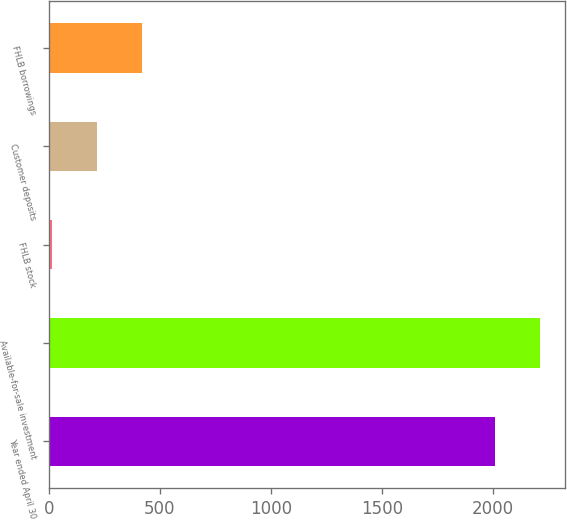Convert chart. <chart><loc_0><loc_0><loc_500><loc_500><bar_chart><fcel>Year ended April 30<fcel>Available-for-sale investment<fcel>FHLB stock<fcel>Customer deposits<fcel>FHLB borrowings<nl><fcel>2012<fcel>2213.2<fcel>15<fcel>216.2<fcel>417.4<nl></chart> 